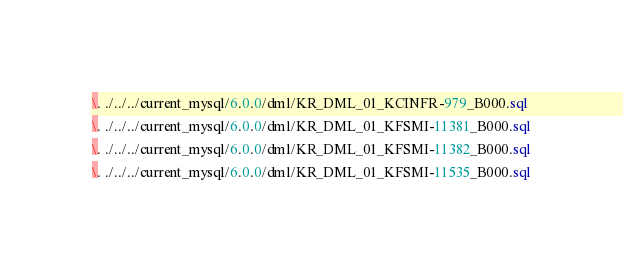<code> <loc_0><loc_0><loc_500><loc_500><_SQL_>\. ./../../current_mysql/6.0.0/dml/KR_DML_01_KCINFR-979_B000.sql
\. ./../../current_mysql/6.0.0/dml/KR_DML_01_KFSMI-11381_B000.sql
\. ./../../current_mysql/6.0.0/dml/KR_DML_01_KFSMI-11382_B000.sql
\. ./../../current_mysql/6.0.0/dml/KR_DML_01_KFSMI-11535_B000.sql</code> 